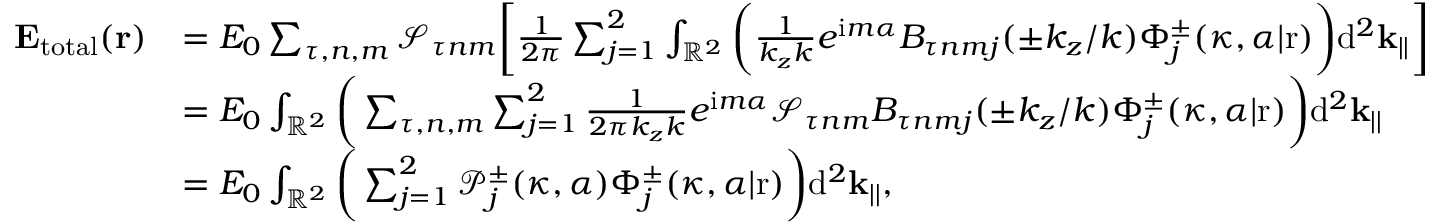Convert formula to latex. <formula><loc_0><loc_0><loc_500><loc_500>\begin{array} { r l } { E _ { t o t a l } ( r ) } & { = E _ { 0 } \sum _ { \tau , n , m } \mathcal { S } _ { \tau n m } \left [ \frac { 1 } { 2 \pi } \sum _ { j = 1 } ^ { 2 } \int _ { \mathbb { R } ^ { 2 } } \left ( \frac { 1 } { k _ { z } k } e ^ { i m \alpha } B _ { \tau n m j } ( \pm k _ { z } / k ) \Phi _ { j } ^ { \pm } ( \kappa , \alpha | r ) \right ) d ^ { 2 } k _ { | | } \right ] } \\ & { = E _ { 0 } \int _ { \mathbb { R } ^ { 2 } } \left ( \sum _ { \tau , n , m } \sum _ { j = 1 } ^ { 2 } \frac { 1 } { 2 \pi k _ { z } k } e ^ { i m \alpha } \mathcal { S } _ { \tau n m } B _ { \tau n m j } ( \pm k _ { z } / k ) \Phi _ { j } ^ { \pm } ( \kappa , \alpha | r ) \right ) d ^ { 2 } k _ { | | } } \\ & { = E _ { 0 } \int _ { \mathbb { R } ^ { 2 } } \left ( \sum _ { j = 1 } ^ { 2 } \mathcal { P } _ { j } ^ { \pm } ( \kappa , \alpha ) \Phi _ { j } ^ { \pm } ( \kappa , \alpha | r ) \right ) d ^ { 2 } k _ { | | } , } \end{array}</formula> 